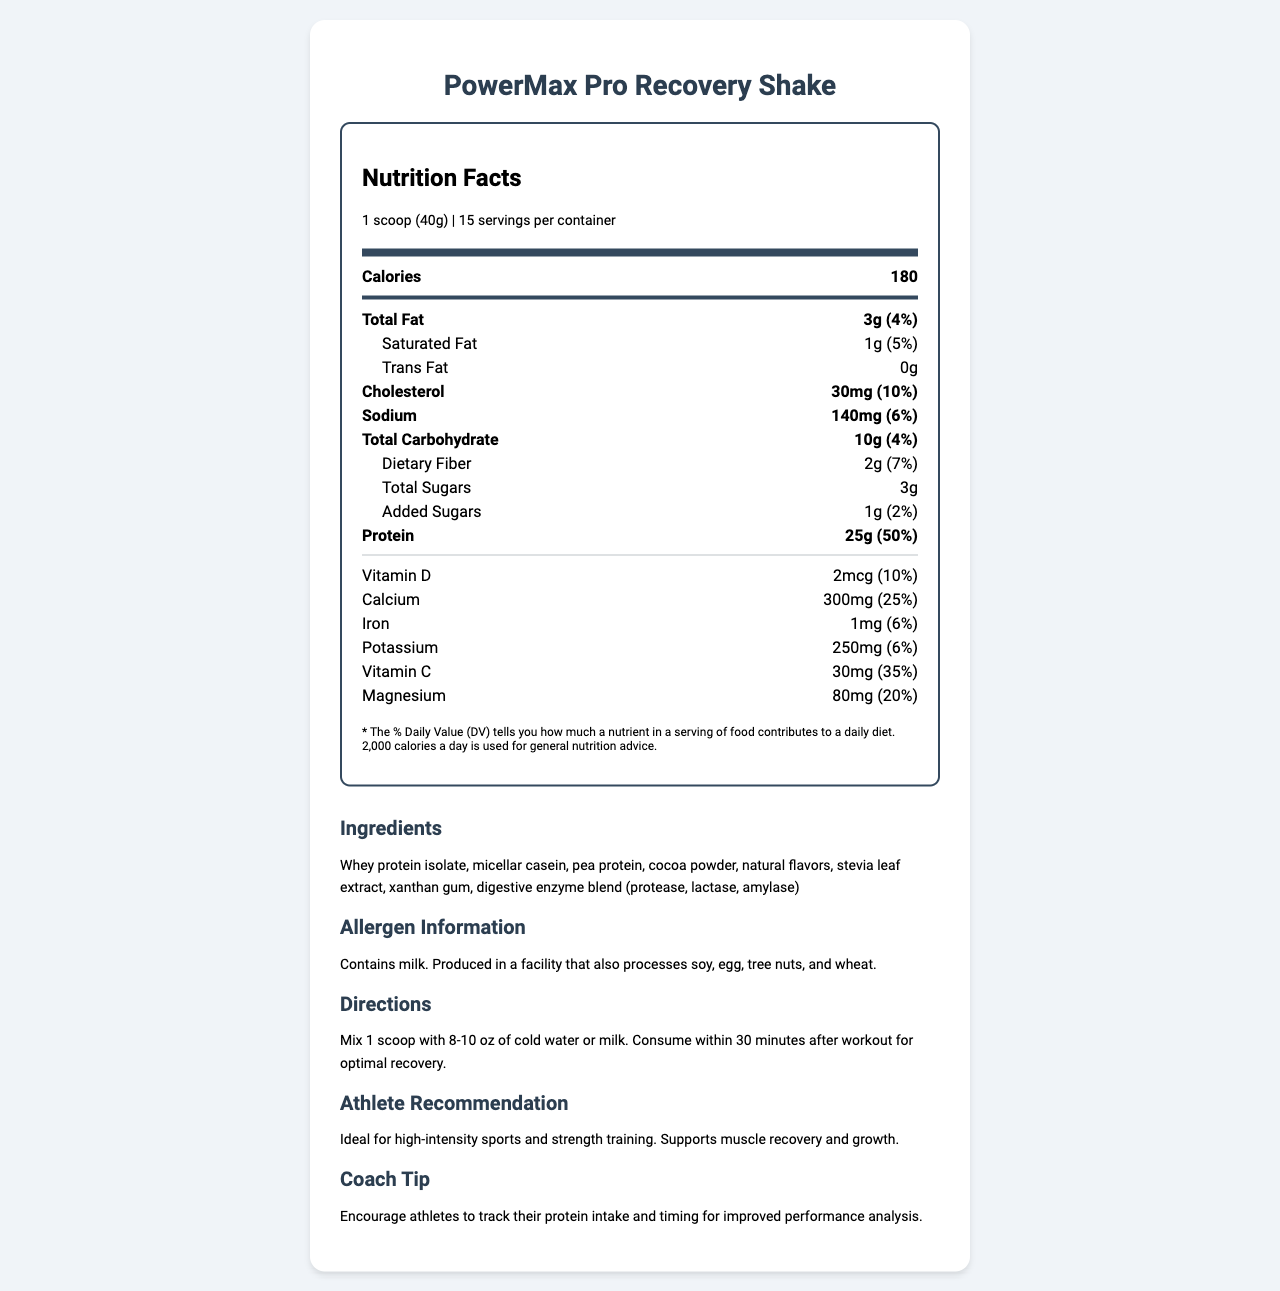what is the serving size of the PowerMax Pro Recovery Shake? The serving size is explicitly mentioned under the "serving info" section at the top of the document.
Answer: 1 scoop (40g) how many servings are there per container? The number of servings per container is provided under the "serving info" section.
Answer: 15 how many calories are in one serving? The calories per serving are displayed in bold as part of the "nutrition-item main" section.
Answer: 180 how much protein is in a serving of the shake? The amount of protein is listed under the "nutrition-item main" section in the nutrition facts.
Answer: 25g what are the ingredients of the shake? The ingredients are listed under the “Ingredients” section at the bottom of the document.
Answer: Whey protein isolate, micellar casein, pea protein, cocoa powder, natural flavors, stevia leaf extract, xanthan gum, digestive enzyme blend (protease, lactase, amylase) what is the total amount of fat in one serving of this product? The total amount of fat is listed in the "nutrition-item main" section under Total Fat.
Answer: 3g how much added sugar does the product contain? The amount of added sugars is displayed in the "nutrition-item sub-item" section under Added Sugars.
Answer: 1g what percentage of the Daily Value for Vitamin D does the shake provide? The daily value percentage for Vitamin D is listed under the "nutrition-item" section.
Answer: 10% Does this product contain any allergens? The allergen information section mentions that it contains milk and is produced in a facility that processes soy, egg, tree nuts, and wheat.
Answer: Yes which of these vitamins is present in the highest amount in the PowerMax Pro Recovery Shake?
A. Vitamin D
B. Calcium
C. Vitamin C
D. Iron Vitamin C is present in the highest amount (30mg, 35% DV), as listed in the "nutrition-item" section.
Answer: C which nutrient contributes the most to the calories in one serving?
i. Protein
ii. Total Fat
iii. Carbohydrates Protein contributes the most at 25g per serving compared to 3g of fat and 10g of carbohydrates.
Answer: i can this product be used for athletes involved in high-intensity sports? The “Athlete Recommendation” section clearly states that it is ideal for high-intensity sports and strength training.
Answer: Yes summarize the document in one sentence. The document includes various sections detailing nutrition information, ingredients, allergen warnings, usage directions, and recommendations for athletes and coaches, thus summarizing its content.
Answer: The document provides a detailed nutrition facts label for the PowerMax Pro Recovery Shake, including its macronutrient breakdown, ingredients, allergen information, and usage recommendations. what are the specific benefits mentioned for athletes using this recovery shake? The Athlete Recommendation section mentions that it is ideal for high-intensity sports and strength training, supporting muscle recovery and growth.
Answer: Supports muscle recovery and growth what other ingredients might be present due to being processed in the same facility? The allergen information indicates potential cross-contamination with soy, egg, tree nuts, and wheat, but exact ingredients are not specified.
Answer: Cannot be determined 